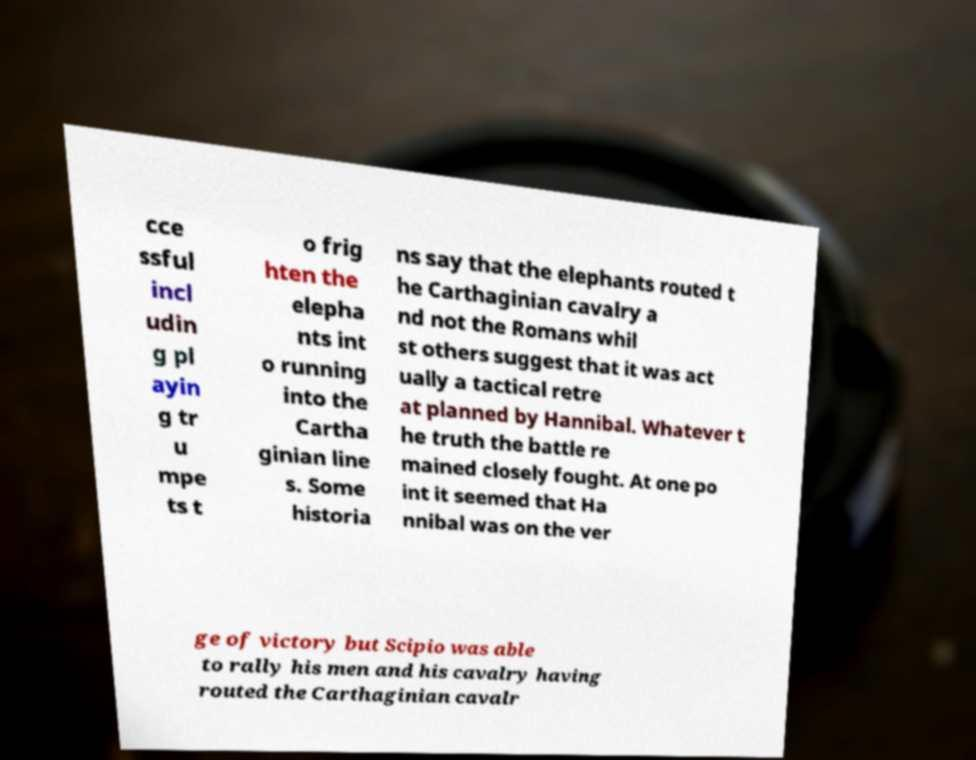What messages or text are displayed in this image? I need them in a readable, typed format. cce ssful incl udin g pl ayin g tr u mpe ts t o frig hten the elepha nts int o running into the Cartha ginian line s. Some historia ns say that the elephants routed t he Carthaginian cavalry a nd not the Romans whil st others suggest that it was act ually a tactical retre at planned by Hannibal. Whatever t he truth the battle re mained closely fought. At one po int it seemed that Ha nnibal was on the ver ge of victory but Scipio was able to rally his men and his cavalry having routed the Carthaginian cavalr 